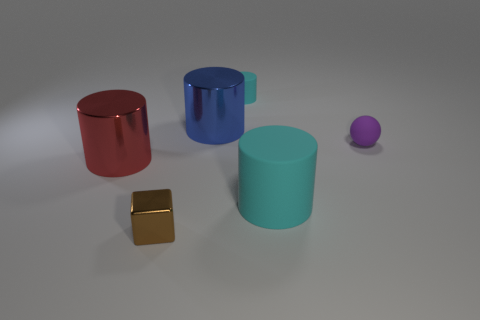Add 1 large cyan metallic balls. How many objects exist? 7 Subtract all cylinders. How many objects are left? 2 Subtract all red spheres. Subtract all tiny cylinders. How many objects are left? 5 Add 3 red metallic objects. How many red metallic objects are left? 4 Add 6 tiny blocks. How many tiny blocks exist? 7 Subtract 0 gray spheres. How many objects are left? 6 